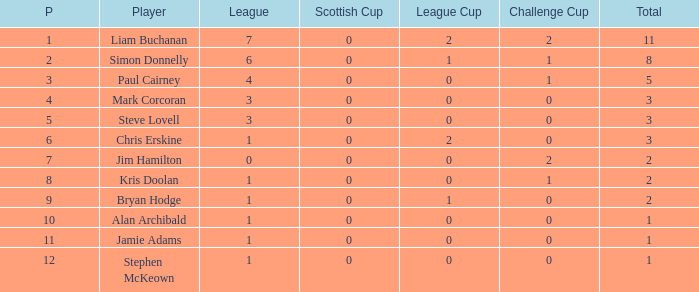What number does bryan hodge wear on his jersey? 1.0. 